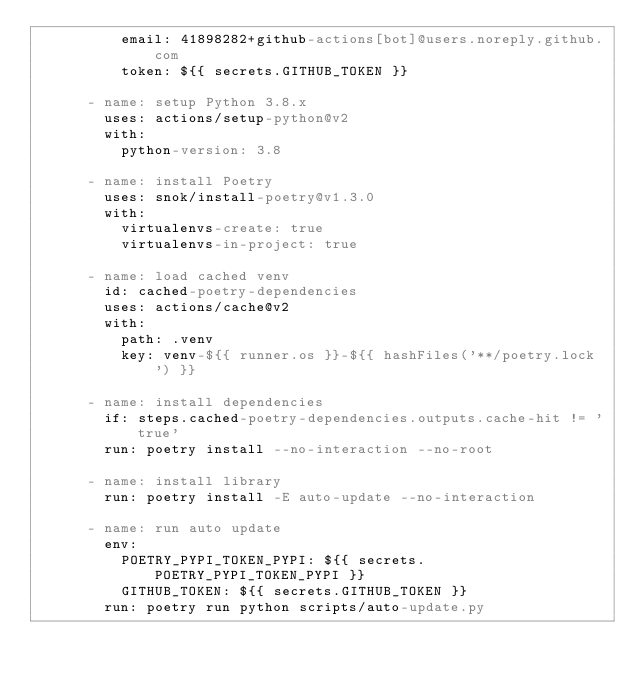Convert code to text. <code><loc_0><loc_0><loc_500><loc_500><_YAML_>          email: 41898282+github-actions[bot]@users.noreply.github.com
          token: ${{ secrets.GITHUB_TOKEN }}

      - name: setup Python 3.8.x
        uses: actions/setup-python@v2
        with:
          python-version: 3.8

      - name: install Poetry
        uses: snok/install-poetry@v1.3.0
        with:
          virtualenvs-create: true
          virtualenvs-in-project: true

      - name: load cached venv
        id: cached-poetry-dependencies
        uses: actions/cache@v2
        with:
          path: .venv
          key: venv-${{ runner.os }}-${{ hashFiles('**/poetry.lock') }}

      - name: install dependencies
        if: steps.cached-poetry-dependencies.outputs.cache-hit != 'true'
        run: poetry install --no-interaction --no-root

      - name: install library
        run: poetry install -E auto-update --no-interaction

      - name: run auto update
        env:
          POETRY_PYPI_TOKEN_PYPI: ${{ secrets.POETRY_PYPI_TOKEN_PYPI }}
          GITHUB_TOKEN: ${{ secrets.GITHUB_TOKEN }}
        run: poetry run python scripts/auto-update.py
</code> 